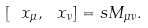Convert formula to latex. <formula><loc_0><loc_0><loc_500><loc_500>[ \ x _ { \mu } , \ x _ { \nu } ] = s M _ { \mu \nu } .</formula> 